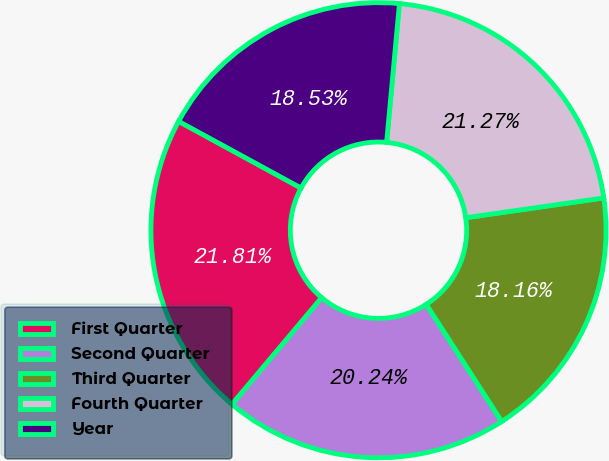Convert chart. <chart><loc_0><loc_0><loc_500><loc_500><pie_chart><fcel>First Quarter<fcel>Second Quarter<fcel>Third Quarter<fcel>Fourth Quarter<fcel>Year<nl><fcel>21.81%<fcel>20.24%<fcel>18.16%<fcel>21.27%<fcel>18.53%<nl></chart> 